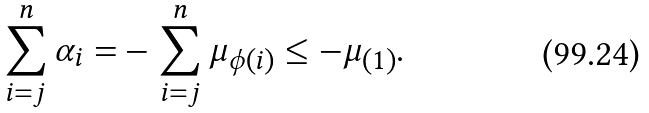Convert formula to latex. <formula><loc_0><loc_0><loc_500><loc_500>\sum _ { i = j } ^ { n } \alpha _ { i } = & - \sum _ { i = j } ^ { n } \mu _ { \phi ( i ) } \leq - \mu _ { ( 1 ) } .</formula> 